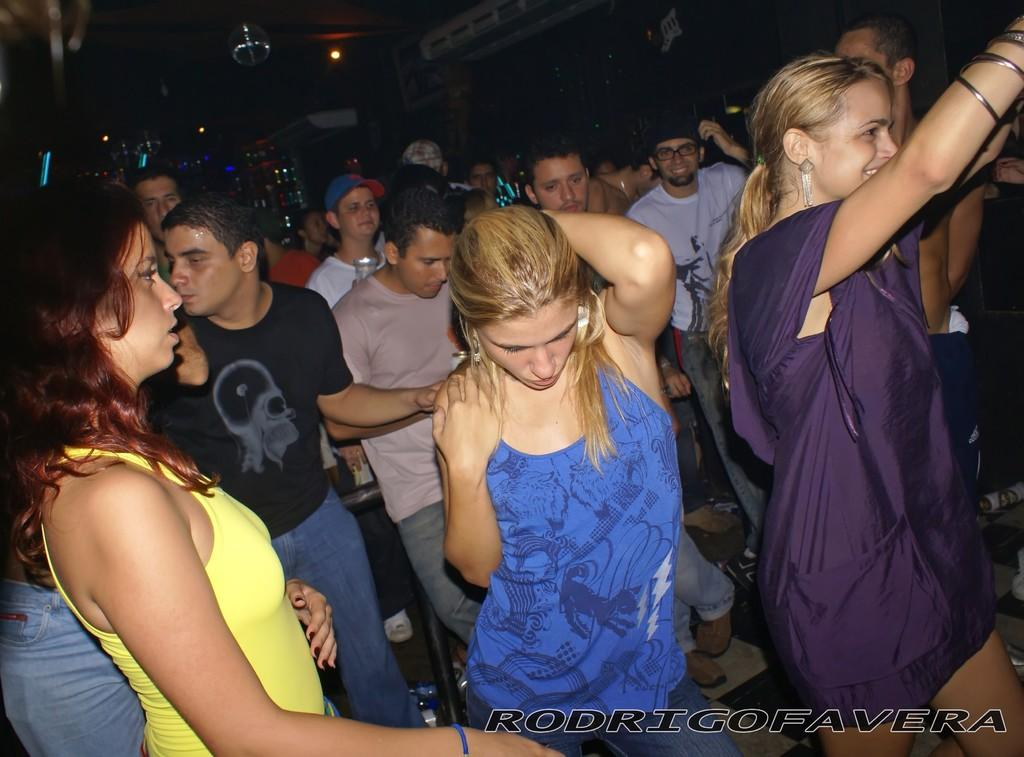What types of people are in the image? There are boys and girls in the image. Where are the boys and girls located in the image? The boys and girls are in the center of the image. What type of bird can be seen attempting to fly in the image? There is no bird present in the image, and therefore no attempt to fly can be observed. 